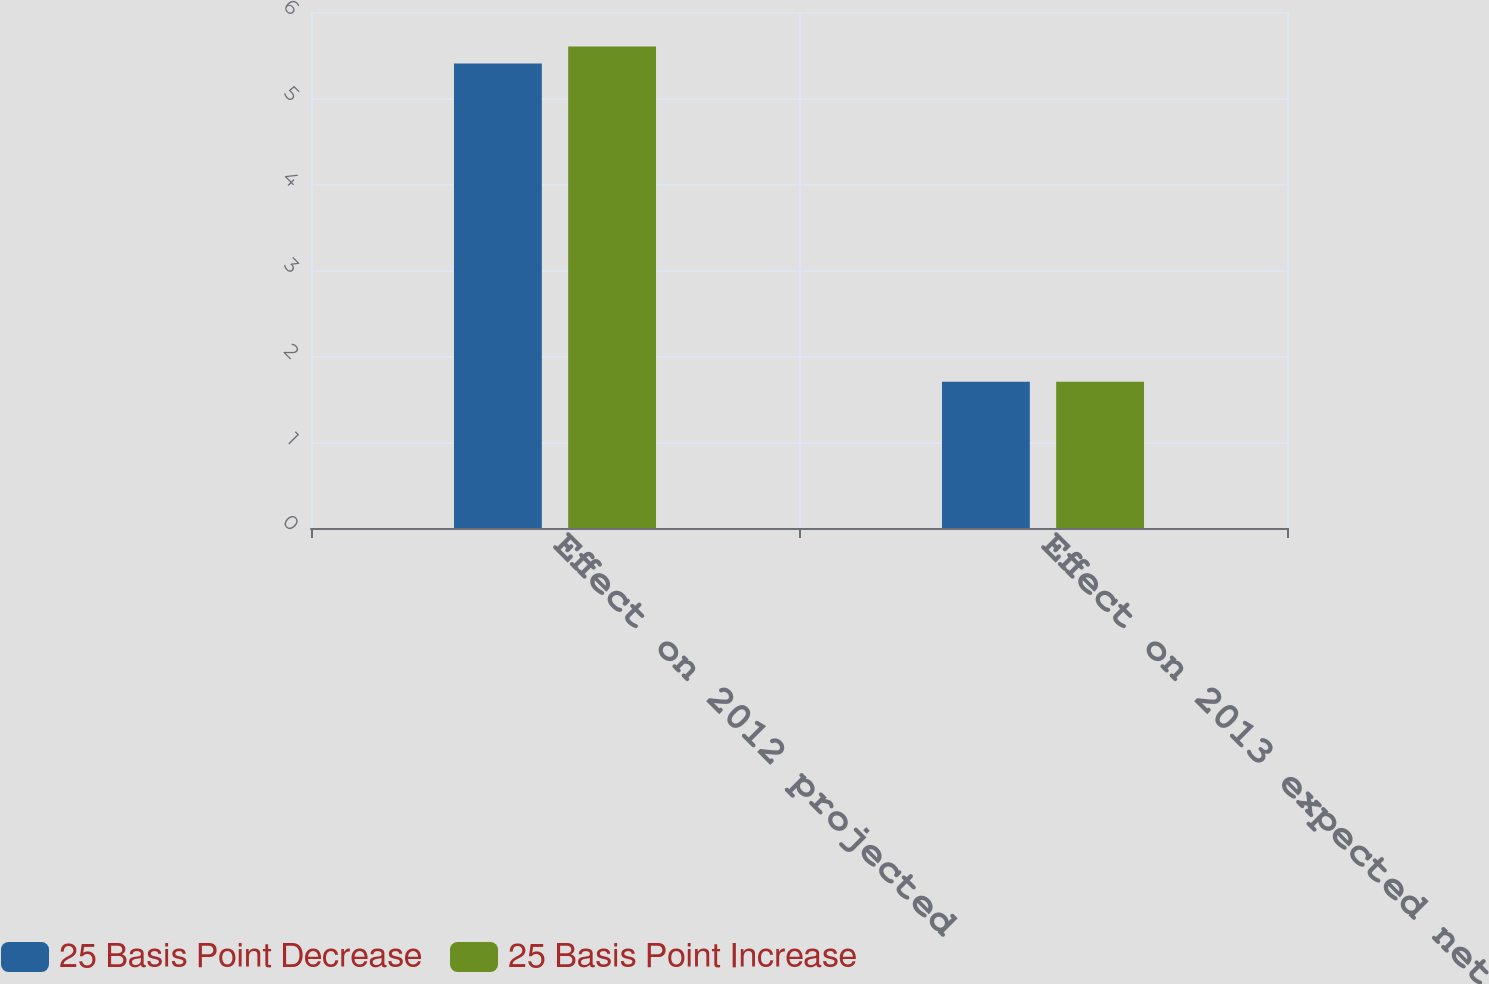<chart> <loc_0><loc_0><loc_500><loc_500><stacked_bar_chart><ecel><fcel>Effect on 2012 projected<fcel>Effect on 2013 expected net<nl><fcel>25 Basis Point Decrease<fcel>5.4<fcel>1.7<nl><fcel>25 Basis Point Increase<fcel>5.6<fcel>1.7<nl></chart> 